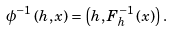Convert formula to latex. <formula><loc_0><loc_0><loc_500><loc_500>\phi ^ { - 1 } \left ( h , x \right ) = \left ( h , F ^ { - 1 } _ { h } \left ( x \right ) \right ) .</formula> 